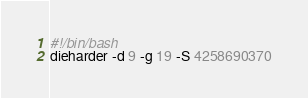<code> <loc_0><loc_0><loc_500><loc_500><_Bash_>#!/bin/bash
dieharder -d 9 -g 19 -S 4258690370
</code> 